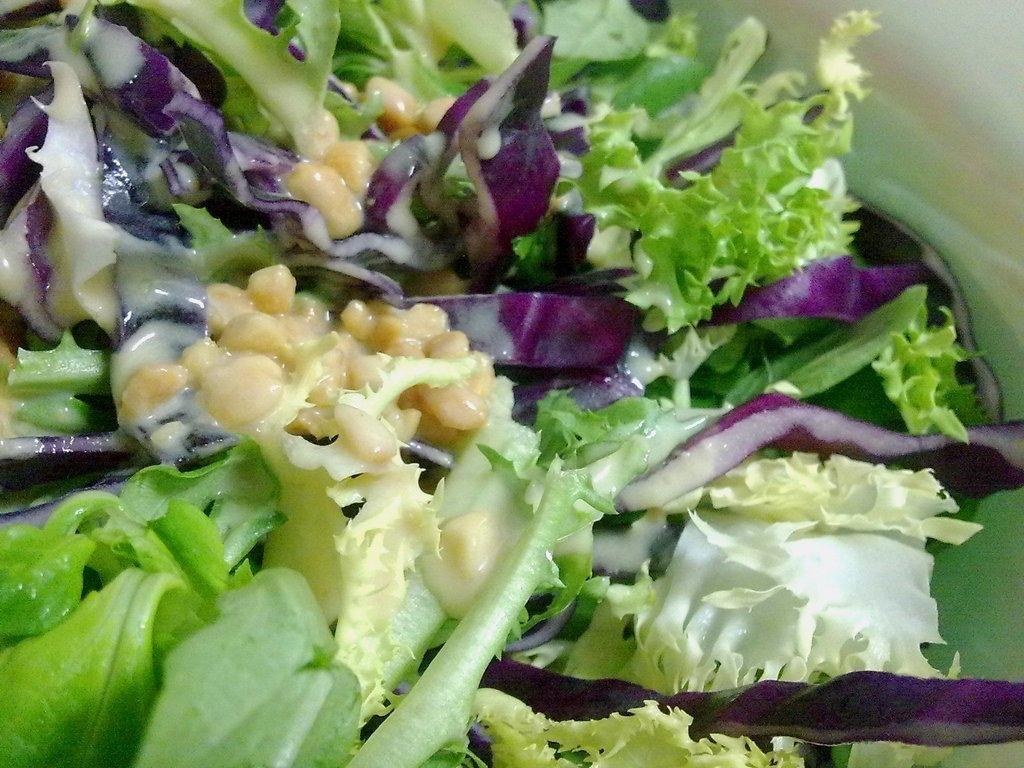What type of dish is featured in the image? There is a salad in the image. What are the main ingredients of the salad? The salad contains leaves and seeds. How does the furniture in the image contribute to the salad's taste? There is no furniture present in the image; it only features a salad with leaves and seeds. 